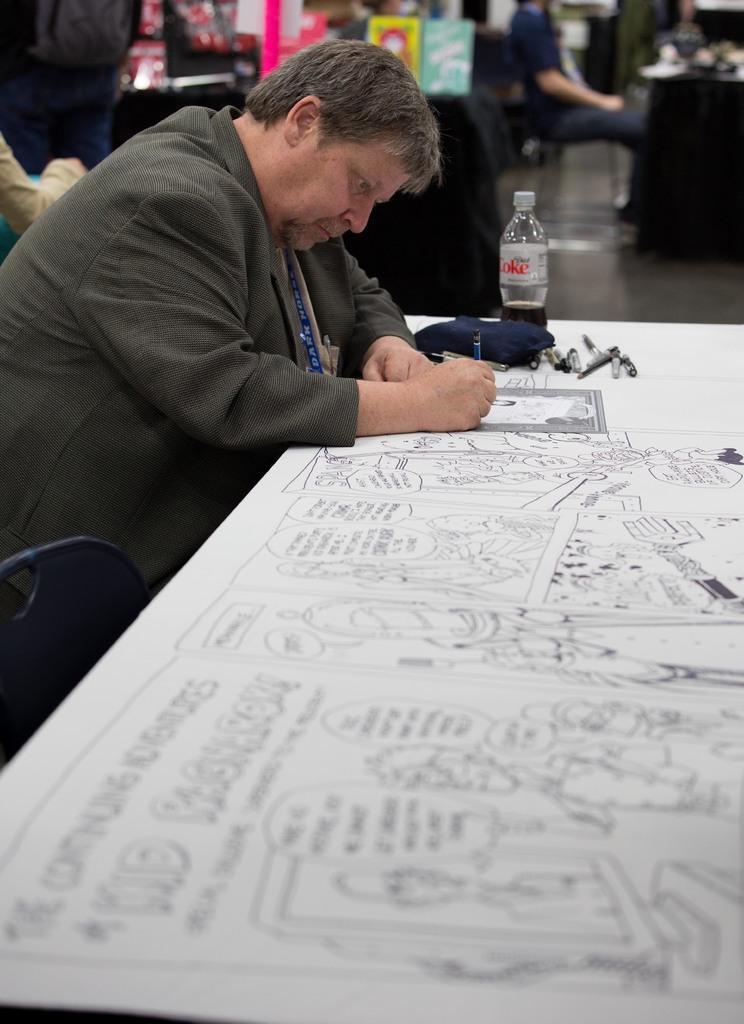Could you give a brief overview of what you see in this image? In this image I can see a man who is sitting on a chair is drawing a sketch on the table. On the table we have a bottle, few sketches and other stuff on it. 